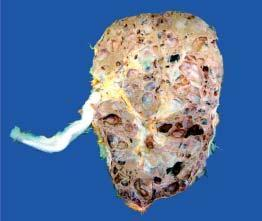what are distorted due to cystic change?
Answer the question using a single word or phrase. Renal pelvis and calyces 